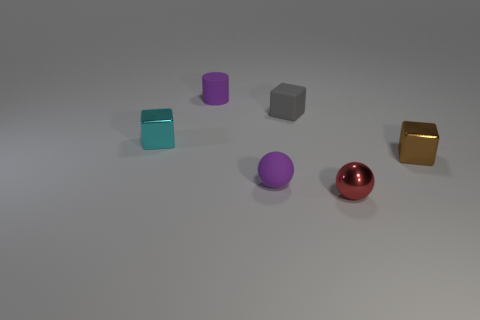Add 3 blue metallic balls. How many objects exist? 9 Subtract all matte cubes. How many cubes are left? 2 Subtract 1 cylinders. How many cylinders are left? 0 Subtract all gray cubes. How many cubes are left? 2 Subtract all balls. How many objects are left? 4 Subtract all red cylinders. How many brown cubes are left? 1 Subtract all small cyan spheres. Subtract all metal blocks. How many objects are left? 4 Add 3 small shiny objects. How many small shiny objects are left? 6 Add 4 shiny balls. How many shiny balls exist? 5 Subtract 0 cyan cylinders. How many objects are left? 6 